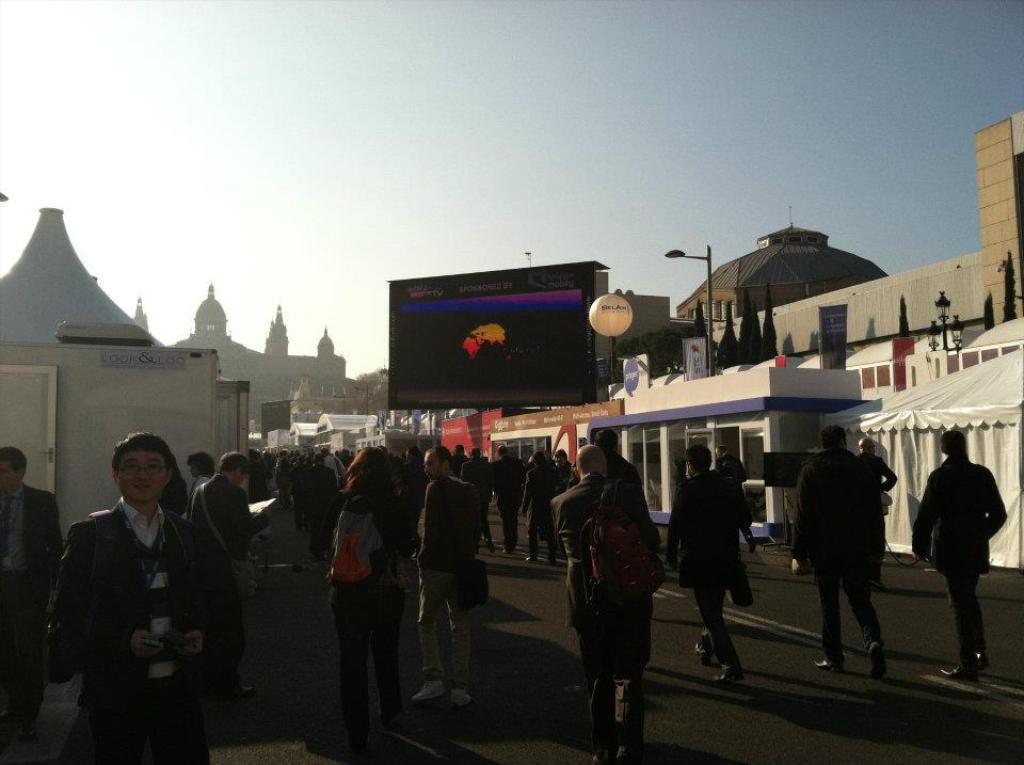Describe this image in one or two sentences. Here in this picture we can see number of people standing and walking on the road and beside them on either side we can see stores and tents present and we can also see buildings present and in the middle we can see a display screen present and we can also see light posts present and we can see the sky is clear. 